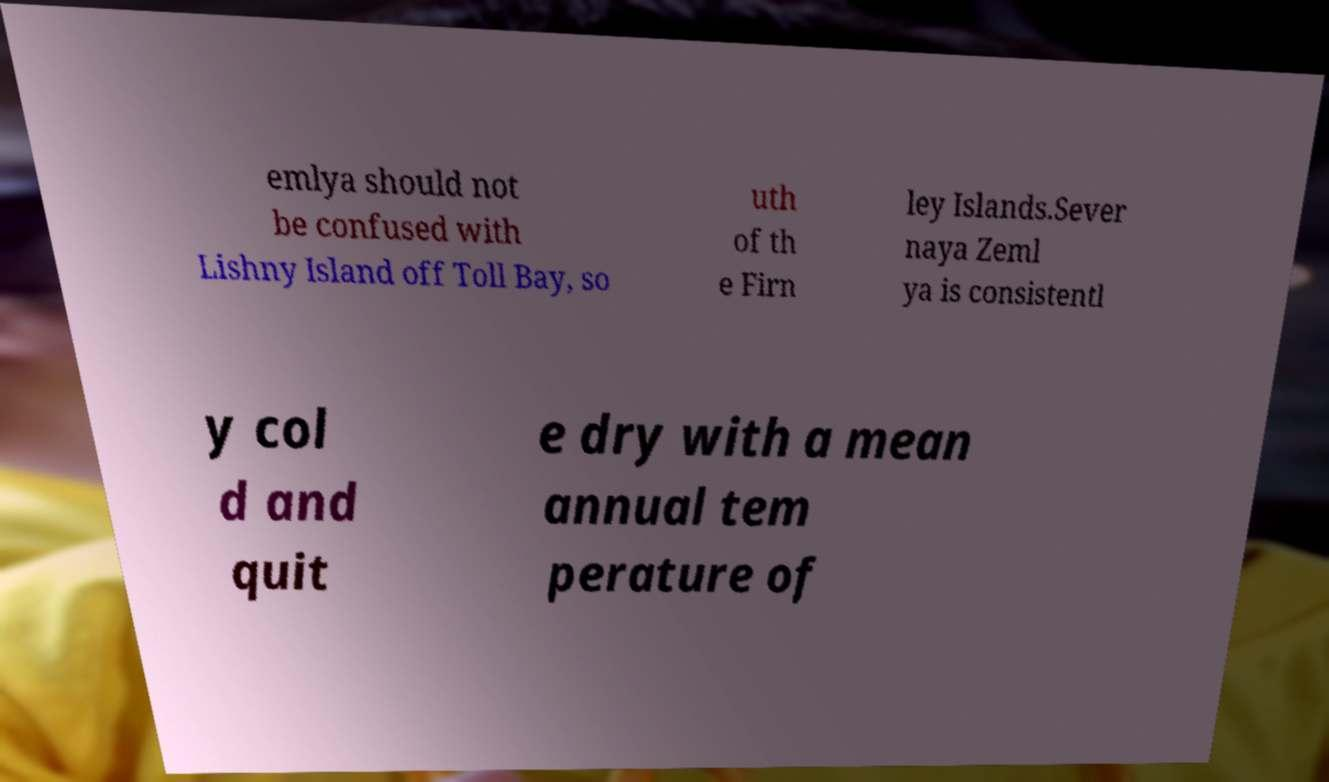Can you accurately transcribe the text from the provided image for me? emlya should not be confused with Lishny Island off Toll Bay, so uth of th e Firn ley Islands.Sever naya Zeml ya is consistentl y col d and quit e dry with a mean annual tem perature of 